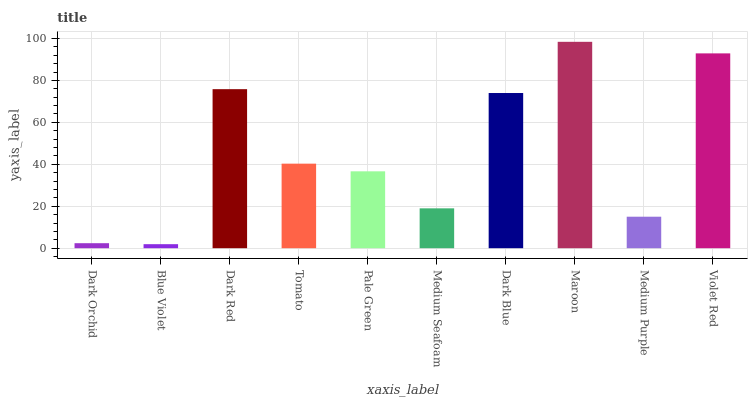Is Blue Violet the minimum?
Answer yes or no. Yes. Is Maroon the maximum?
Answer yes or no. Yes. Is Dark Red the minimum?
Answer yes or no. No. Is Dark Red the maximum?
Answer yes or no. No. Is Dark Red greater than Blue Violet?
Answer yes or no. Yes. Is Blue Violet less than Dark Red?
Answer yes or no. Yes. Is Blue Violet greater than Dark Red?
Answer yes or no. No. Is Dark Red less than Blue Violet?
Answer yes or no. No. Is Tomato the high median?
Answer yes or no. Yes. Is Pale Green the low median?
Answer yes or no. Yes. Is Pale Green the high median?
Answer yes or no. No. Is Tomato the low median?
Answer yes or no. No. 